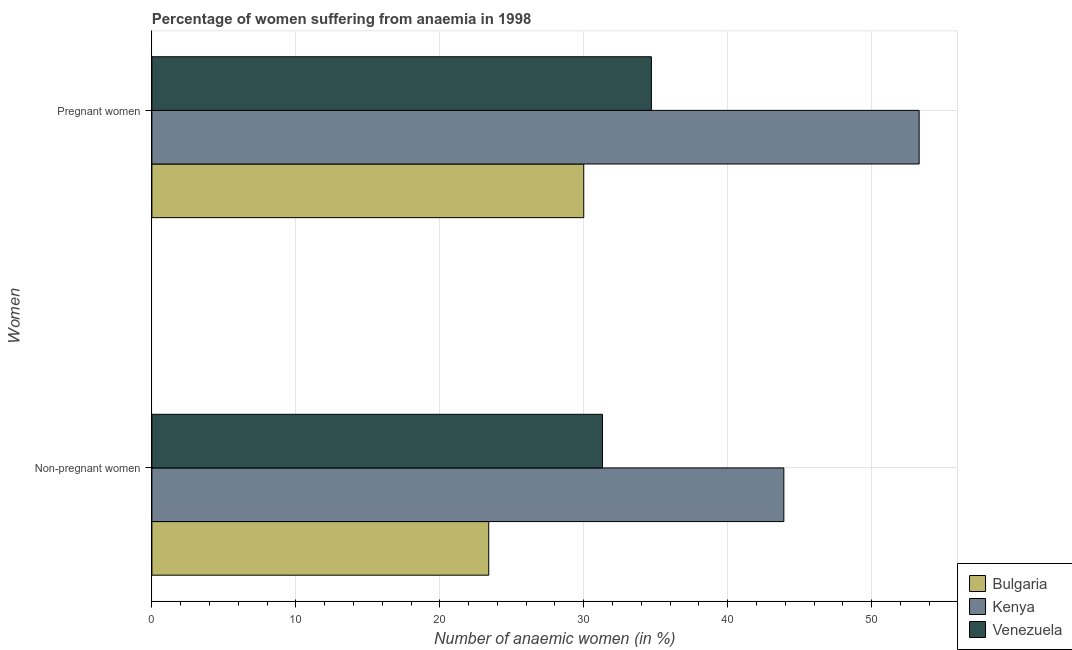Are the number of bars per tick equal to the number of legend labels?
Your answer should be compact. Yes. How many bars are there on the 2nd tick from the top?
Provide a short and direct response. 3. What is the label of the 2nd group of bars from the top?
Provide a succinct answer. Non-pregnant women. What is the percentage of pregnant anaemic women in Venezuela?
Give a very brief answer. 34.7. Across all countries, what is the maximum percentage of non-pregnant anaemic women?
Provide a succinct answer. 43.9. Across all countries, what is the minimum percentage of non-pregnant anaemic women?
Make the answer very short. 23.4. In which country was the percentage of pregnant anaemic women maximum?
Your answer should be very brief. Kenya. What is the total percentage of non-pregnant anaemic women in the graph?
Make the answer very short. 98.6. What is the difference between the percentage of non-pregnant anaemic women in Bulgaria and that in Kenya?
Your response must be concise. -20.5. What is the difference between the percentage of non-pregnant anaemic women in Bulgaria and the percentage of pregnant anaemic women in Venezuela?
Keep it short and to the point. -11.3. What is the average percentage of pregnant anaemic women per country?
Your response must be concise. 39.33. What is the difference between the percentage of non-pregnant anaemic women and percentage of pregnant anaemic women in Bulgaria?
Your answer should be very brief. -6.6. In how many countries, is the percentage of non-pregnant anaemic women greater than 12 %?
Offer a terse response. 3. What is the ratio of the percentage of pregnant anaemic women in Bulgaria to that in Kenya?
Your response must be concise. 0.56. In how many countries, is the percentage of pregnant anaemic women greater than the average percentage of pregnant anaemic women taken over all countries?
Your response must be concise. 1. What does the 2nd bar from the bottom in Pregnant women represents?
Offer a terse response. Kenya. How many bars are there?
Offer a very short reply. 6. Are the values on the major ticks of X-axis written in scientific E-notation?
Your answer should be very brief. No. Does the graph contain grids?
Offer a terse response. Yes. How many legend labels are there?
Give a very brief answer. 3. How are the legend labels stacked?
Keep it short and to the point. Vertical. What is the title of the graph?
Your answer should be very brief. Percentage of women suffering from anaemia in 1998. What is the label or title of the X-axis?
Provide a short and direct response. Number of anaemic women (in %). What is the label or title of the Y-axis?
Ensure brevity in your answer.  Women. What is the Number of anaemic women (in %) of Bulgaria in Non-pregnant women?
Provide a short and direct response. 23.4. What is the Number of anaemic women (in %) of Kenya in Non-pregnant women?
Your response must be concise. 43.9. What is the Number of anaemic women (in %) of Venezuela in Non-pregnant women?
Offer a terse response. 31.3. What is the Number of anaemic women (in %) of Bulgaria in Pregnant women?
Your answer should be very brief. 30. What is the Number of anaemic women (in %) of Kenya in Pregnant women?
Your response must be concise. 53.3. What is the Number of anaemic women (in %) of Venezuela in Pregnant women?
Your answer should be compact. 34.7. Across all Women, what is the maximum Number of anaemic women (in %) in Kenya?
Give a very brief answer. 53.3. Across all Women, what is the maximum Number of anaemic women (in %) in Venezuela?
Your answer should be compact. 34.7. Across all Women, what is the minimum Number of anaemic women (in %) in Bulgaria?
Provide a succinct answer. 23.4. Across all Women, what is the minimum Number of anaemic women (in %) in Kenya?
Your response must be concise. 43.9. Across all Women, what is the minimum Number of anaemic women (in %) of Venezuela?
Offer a very short reply. 31.3. What is the total Number of anaemic women (in %) in Bulgaria in the graph?
Provide a short and direct response. 53.4. What is the total Number of anaemic women (in %) of Kenya in the graph?
Your answer should be compact. 97.2. What is the total Number of anaemic women (in %) in Venezuela in the graph?
Provide a succinct answer. 66. What is the difference between the Number of anaemic women (in %) in Kenya in Non-pregnant women and that in Pregnant women?
Give a very brief answer. -9.4. What is the difference between the Number of anaemic women (in %) in Bulgaria in Non-pregnant women and the Number of anaemic women (in %) in Kenya in Pregnant women?
Give a very brief answer. -29.9. What is the difference between the Number of anaemic women (in %) of Bulgaria in Non-pregnant women and the Number of anaemic women (in %) of Venezuela in Pregnant women?
Your response must be concise. -11.3. What is the difference between the Number of anaemic women (in %) of Kenya in Non-pregnant women and the Number of anaemic women (in %) of Venezuela in Pregnant women?
Make the answer very short. 9.2. What is the average Number of anaemic women (in %) in Bulgaria per Women?
Keep it short and to the point. 26.7. What is the average Number of anaemic women (in %) of Kenya per Women?
Provide a short and direct response. 48.6. What is the average Number of anaemic women (in %) in Venezuela per Women?
Your answer should be very brief. 33. What is the difference between the Number of anaemic women (in %) in Bulgaria and Number of anaemic women (in %) in Kenya in Non-pregnant women?
Provide a short and direct response. -20.5. What is the difference between the Number of anaemic women (in %) in Bulgaria and Number of anaemic women (in %) in Venezuela in Non-pregnant women?
Make the answer very short. -7.9. What is the difference between the Number of anaemic women (in %) in Kenya and Number of anaemic women (in %) in Venezuela in Non-pregnant women?
Your answer should be compact. 12.6. What is the difference between the Number of anaemic women (in %) of Bulgaria and Number of anaemic women (in %) of Kenya in Pregnant women?
Your answer should be compact. -23.3. What is the difference between the Number of anaemic women (in %) of Kenya and Number of anaemic women (in %) of Venezuela in Pregnant women?
Give a very brief answer. 18.6. What is the ratio of the Number of anaemic women (in %) in Bulgaria in Non-pregnant women to that in Pregnant women?
Ensure brevity in your answer.  0.78. What is the ratio of the Number of anaemic women (in %) in Kenya in Non-pregnant women to that in Pregnant women?
Your response must be concise. 0.82. What is the ratio of the Number of anaemic women (in %) of Venezuela in Non-pregnant women to that in Pregnant women?
Your answer should be compact. 0.9. What is the difference between the highest and the second highest Number of anaemic women (in %) of Kenya?
Ensure brevity in your answer.  9.4. What is the difference between the highest and the second highest Number of anaemic women (in %) of Venezuela?
Your answer should be compact. 3.4. What is the difference between the highest and the lowest Number of anaemic women (in %) in Venezuela?
Provide a succinct answer. 3.4. 